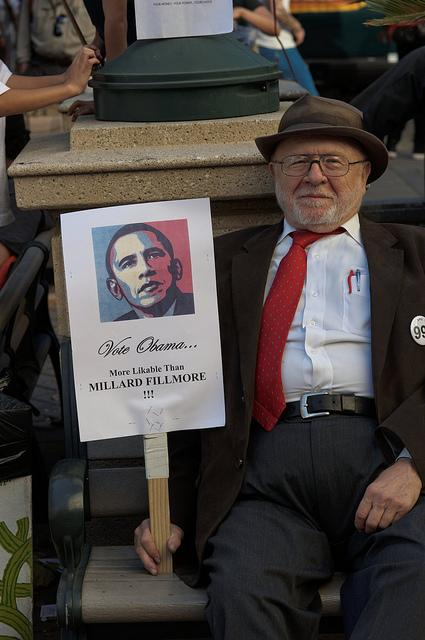Under what circumstance might children wear the red item the man is wearing? Please explain your reasoning. school. It is a necktie and sometimes ties are used as a part of a uniform. 